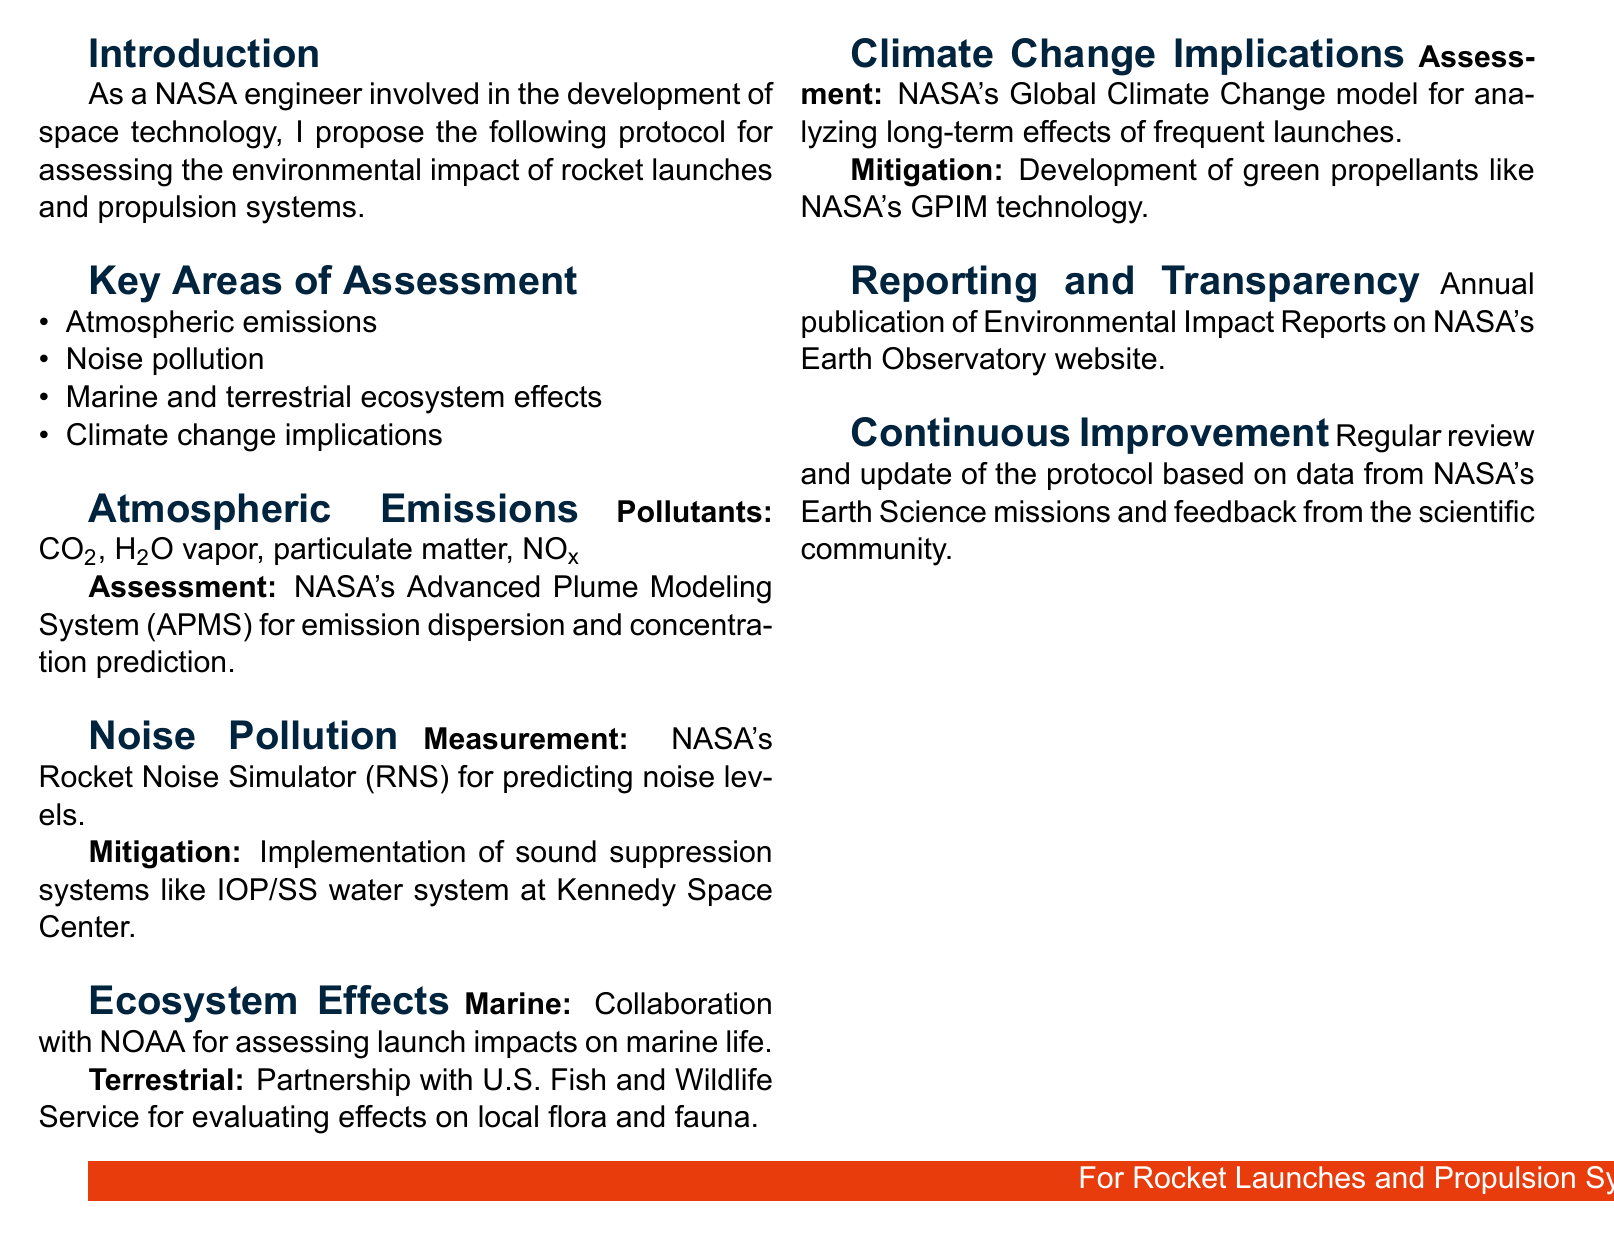What are the key areas of assessment? The key areas of assessment are listed specifically under that heading in the document, which includes atmospheric emissions, noise pollution, marine and terrestrial ecosystem effects, and climate change implications.
Answer: Atmospheric emissions, noise pollution, marine and terrestrial ecosystem effects, climate change implications Which pollutants are assessed under atmospheric emissions? The document mentions specific pollutants that are being assessed under atmospheric emissions. These include carbon dioxide, water vapor, particulate matter, and nitrogen oxides.
Answer: CO2, H2O vapor, particulate matter, NOx What system does NASA use for noise prediction? The document indicates the use of a particular system for predicting noise levels, specifically a simulator created for this purpose.
Answer: Rocket Noise Simulator Which organization collaborates with NASA on marine ecosystem effects? The document refers to a specific organization that collaborates with NASA regarding marine life assessments in the context of rocket launches.
Answer: NOAA What is the annual publication mentioned in the document? The document discusses a publication that is released annually to provide updates on environmental assessments, specifying its platform for publication.
Answer: Environmental Impact Reports How often is the protocol reviewed according to the document? The document states the frequency with which the protocol will be updated based on feedback and data from certain sources.
Answer: Regularly 